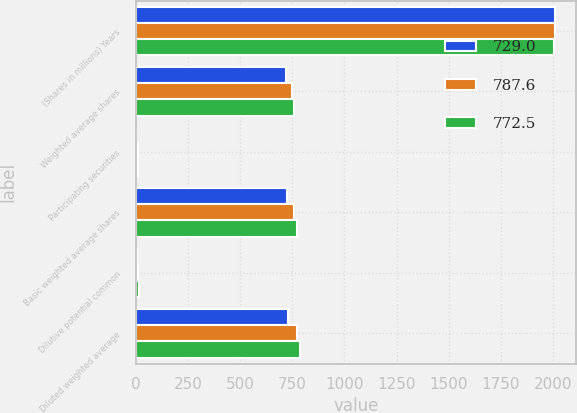<chart> <loc_0><loc_0><loc_500><loc_500><stacked_bar_chart><ecel><fcel>(Shares in millions) Years<fcel>Weighted average shares<fcel>Participating securities<fcel>Basic weighted average shares<fcel>Dilutive potential common<fcel>Diluted weighted average<nl><fcel>729<fcel>2008<fcel>719.9<fcel>2.7<fcel>722.6<fcel>6.4<fcel>729<nl><fcel>787.6<fcel>2007<fcel>750.5<fcel>8.8<fcel>759.3<fcel>13.2<fcel>772.5<nl><fcel>772.5<fcel>2006<fcel>760.5<fcel>10.5<fcel>771<fcel>16.6<fcel>787.6<nl></chart> 